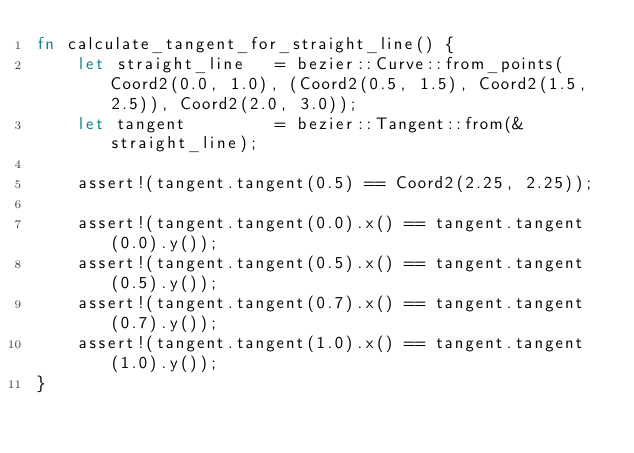<code> <loc_0><loc_0><loc_500><loc_500><_Rust_>fn calculate_tangent_for_straight_line() {
    let straight_line   = bezier::Curve::from_points(Coord2(0.0, 1.0), (Coord2(0.5, 1.5), Coord2(1.5, 2.5)), Coord2(2.0, 3.0));
    let tangent         = bezier::Tangent::from(&straight_line);

    assert!(tangent.tangent(0.5) == Coord2(2.25, 2.25));

    assert!(tangent.tangent(0.0).x() == tangent.tangent(0.0).y());
    assert!(tangent.tangent(0.5).x() == tangent.tangent(0.5).y());
    assert!(tangent.tangent(0.7).x() == tangent.tangent(0.7).y());
    assert!(tangent.tangent(1.0).x() == tangent.tangent(1.0).y());
}
</code> 